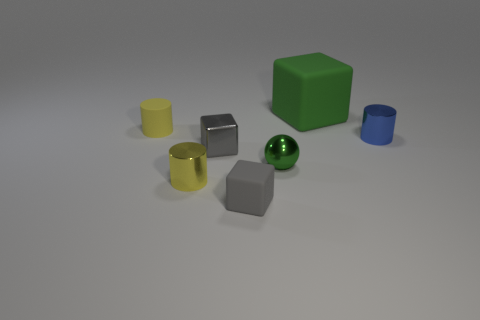There is a tiny object that is the same color as the metal cube; what material is it?
Offer a terse response. Rubber. Does the green metal sphere have the same size as the gray block right of the gray metallic block?
Ensure brevity in your answer.  Yes. Is there a rubber cylinder of the same color as the tiny sphere?
Offer a very short reply. No. Are there any small green rubber things that have the same shape as the tiny yellow matte thing?
Make the answer very short. No. What is the shape of the matte object that is left of the big green matte object and behind the tiny blue shiny thing?
Your answer should be compact. Cylinder. What number of other objects have the same material as the big green thing?
Ensure brevity in your answer.  2. Is the number of spheres behind the small yellow rubber cylinder less than the number of large rubber cubes?
Ensure brevity in your answer.  Yes. There is a tiny gray object that is in front of the shiny cube; are there any blue objects left of it?
Provide a short and direct response. No. Are there any other things that have the same shape as the tiny blue shiny object?
Your answer should be very brief. Yes. Is the gray metallic cube the same size as the ball?
Make the answer very short. Yes. 